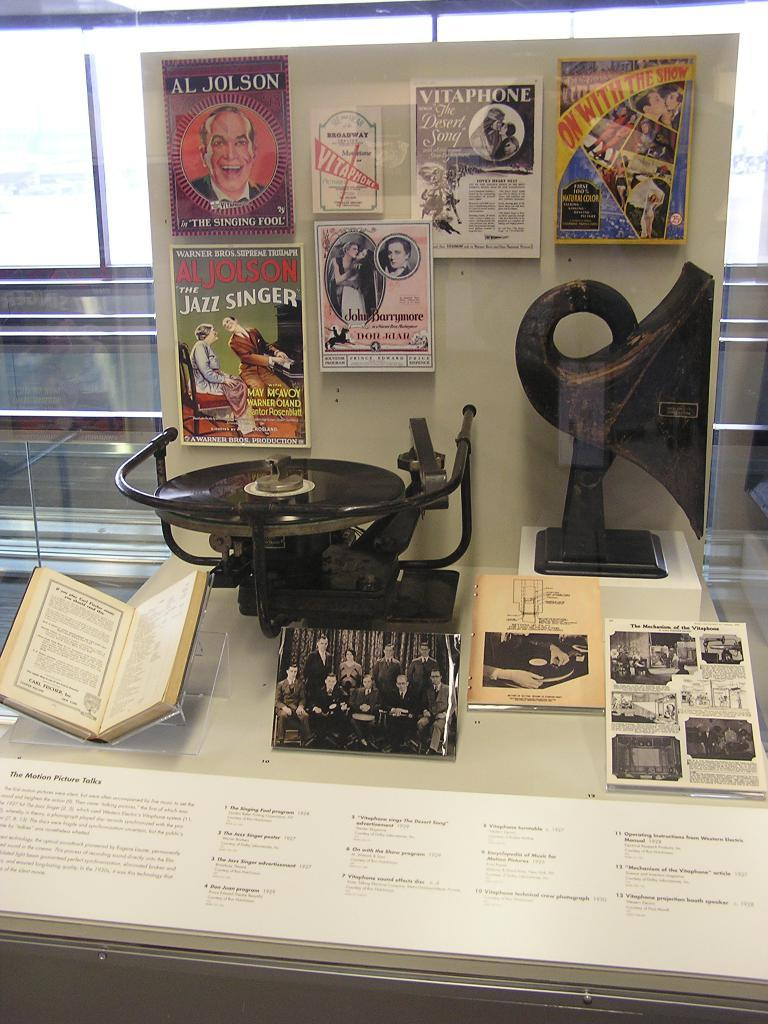<image>
Summarize the visual content of the image. Display that shows a poster saying Al Jolson. 